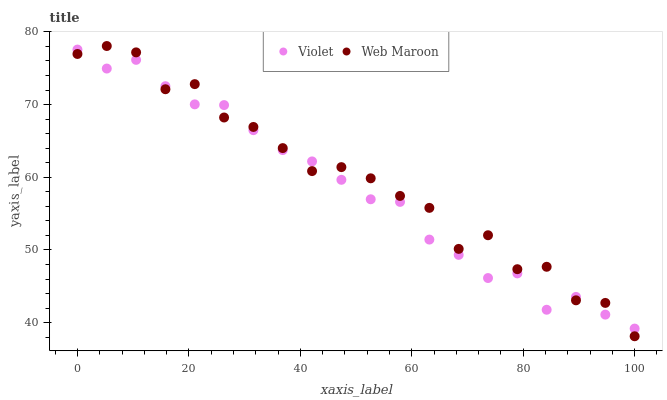Does Violet have the minimum area under the curve?
Answer yes or no. Yes. Does Web Maroon have the maximum area under the curve?
Answer yes or no. Yes. Does Violet have the maximum area under the curve?
Answer yes or no. No. Is Violet the smoothest?
Answer yes or no. Yes. Is Web Maroon the roughest?
Answer yes or no. Yes. Is Violet the roughest?
Answer yes or no. No. Does Web Maroon have the lowest value?
Answer yes or no. Yes. Does Violet have the lowest value?
Answer yes or no. No. Does Web Maroon have the highest value?
Answer yes or no. Yes. Does Violet have the highest value?
Answer yes or no. No. Does Violet intersect Web Maroon?
Answer yes or no. Yes. Is Violet less than Web Maroon?
Answer yes or no. No. Is Violet greater than Web Maroon?
Answer yes or no. No. 